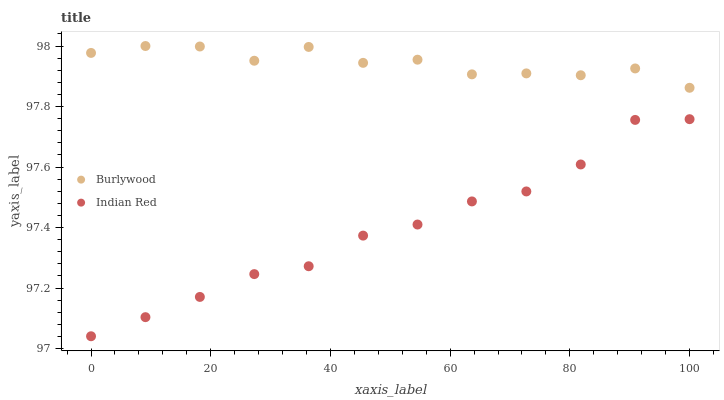Does Indian Red have the minimum area under the curve?
Answer yes or no. Yes. Does Burlywood have the maximum area under the curve?
Answer yes or no. Yes. Does Indian Red have the maximum area under the curve?
Answer yes or no. No. Is Indian Red the smoothest?
Answer yes or no. Yes. Is Burlywood the roughest?
Answer yes or no. Yes. Is Indian Red the roughest?
Answer yes or no. No. Does Indian Red have the lowest value?
Answer yes or no. Yes. Does Burlywood have the highest value?
Answer yes or no. Yes. Does Indian Red have the highest value?
Answer yes or no. No. Is Indian Red less than Burlywood?
Answer yes or no. Yes. Is Burlywood greater than Indian Red?
Answer yes or no. Yes. Does Indian Red intersect Burlywood?
Answer yes or no. No. 